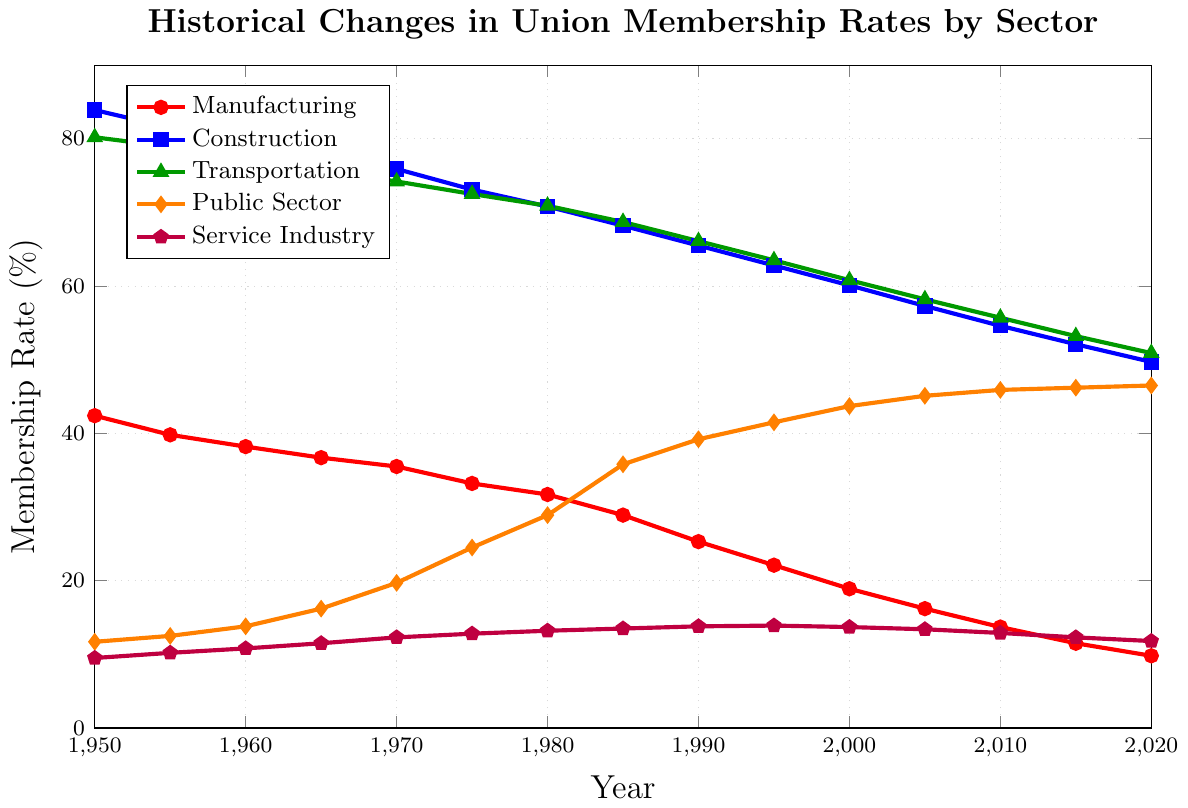What's the union membership rate for the Public Sector in 2020? Look at the orange line for the Public Sector at the year 2020 on the x-axis. The y-value for this point is 46.5.
Answer: 46.5% Which sector had the highest union membership rate in 1950? Compare the y-values of all sectors at the year 1950 on the x-axis. The blue line representing Construction is the highest, with a y-value of 83.9.
Answer: Construction Has the union membership rate in the Service Industry been increasing or decreasing since 1950? Observe the purple line representing the Service Industry. It starts at 9.5 in 1950 and generally trends downward to 11.8 in 2020. This indicates a decreasing trend.
Answer: Decreasing What's the total decline in union membership rate in the Manufacturing sector from 1950 to 2020? The union membership rate for Manufacturing is 42.4 in 1950 and 9.8 in 2020. The decline can be calculated by 42.4 - 9.8 = 32.6.
Answer: 32.6 By how much did the union membership rate in the Public Sector increase from 1950 to 2020? The union membership rate for the Public Sector was 11.7 in 1950 and increased to 46.5 in 2020. Calculate the increase by 46.5 - 11.7 = 34.8.
Answer: 34.8 By how much did the union membership rate in the Transportation sector decrease between 1970 and 1990? The union membership rate for the Transportation sector was 74.2 in 1970 and 66.1 in 1990. Calculate the decrease by 74.2 - 66.1 = 8.1.
Answer: 8.1 